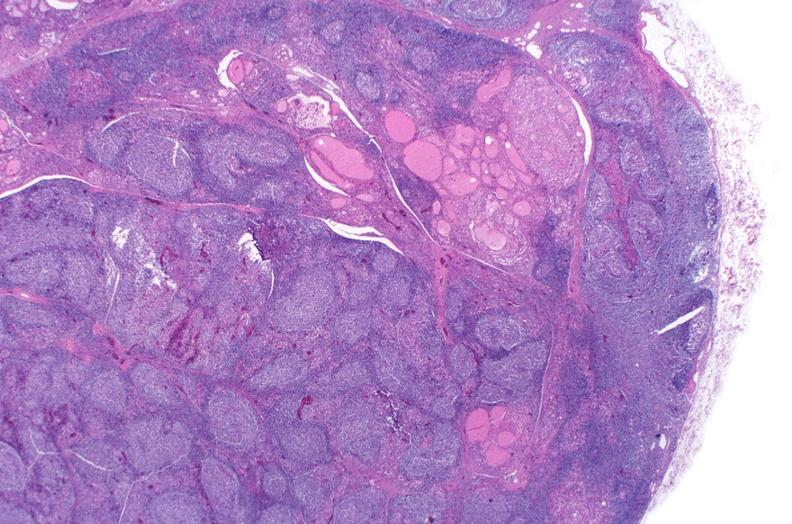what is present?
Answer the question using a single word or phrase. Endocrine 